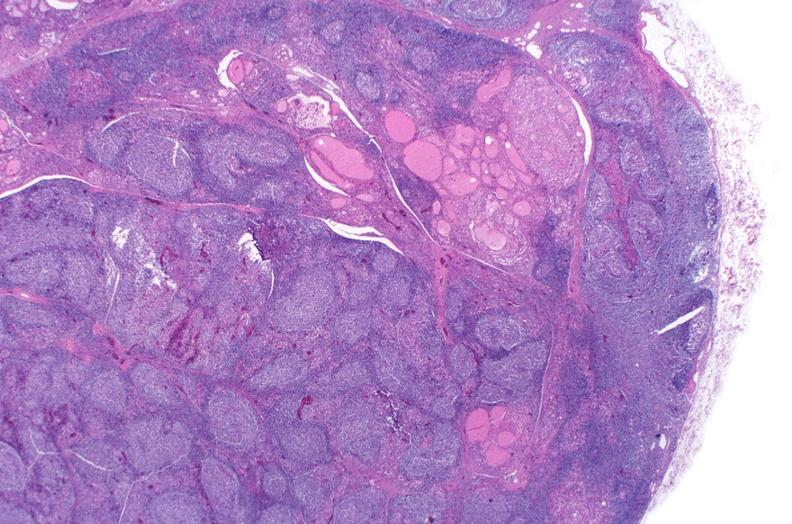what is present?
Answer the question using a single word or phrase. Endocrine 